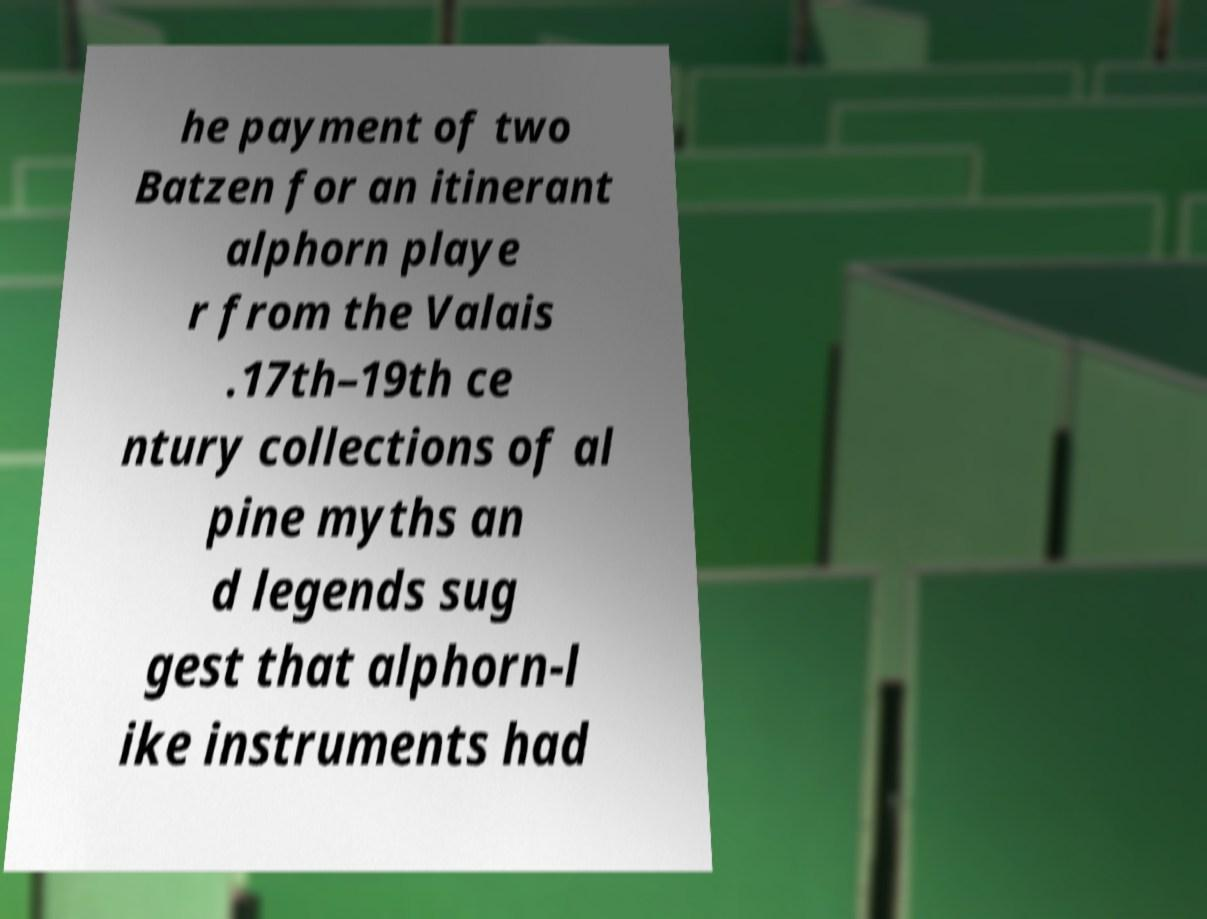Please read and relay the text visible in this image. What does it say? he payment of two Batzen for an itinerant alphorn playe r from the Valais .17th–19th ce ntury collections of al pine myths an d legends sug gest that alphorn-l ike instruments had 